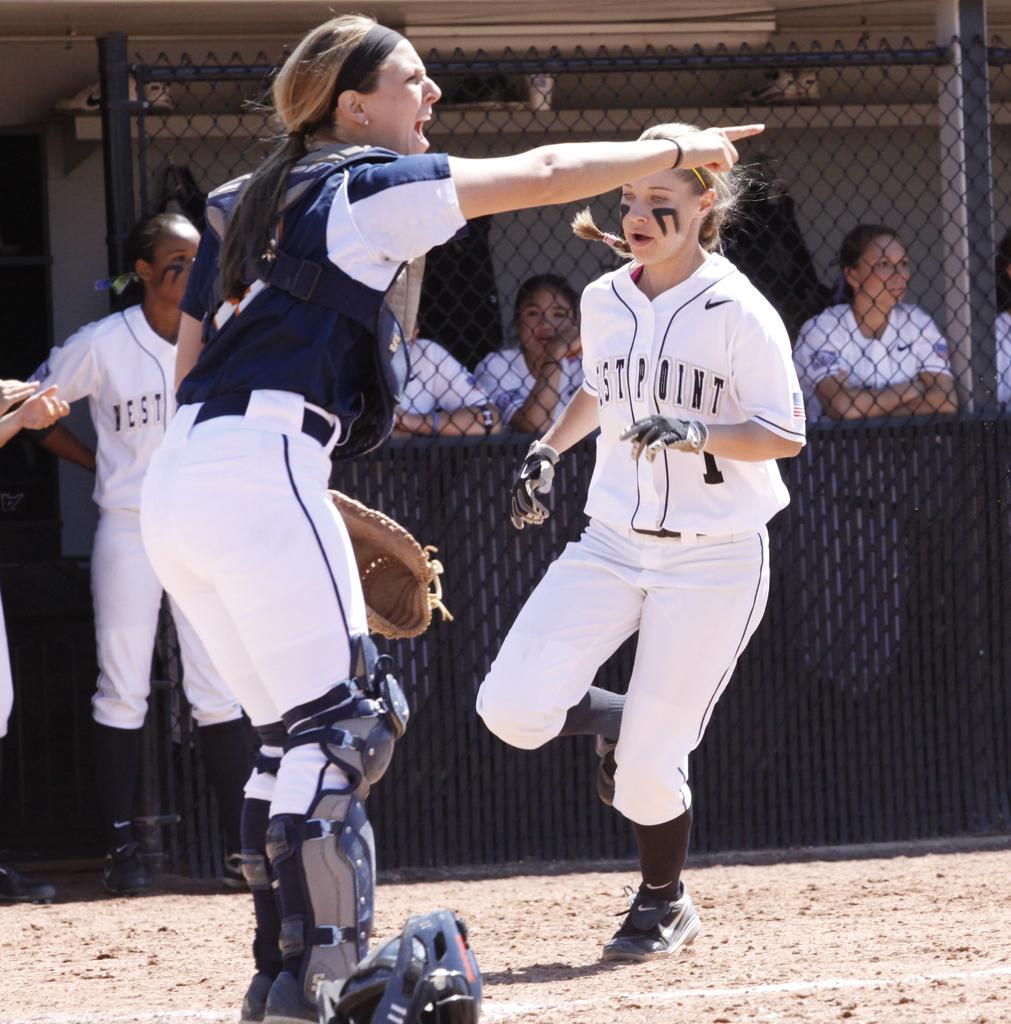<image>
Summarize the visual content of the image. WESTPOINT is the team the runner is obviously playing for. 